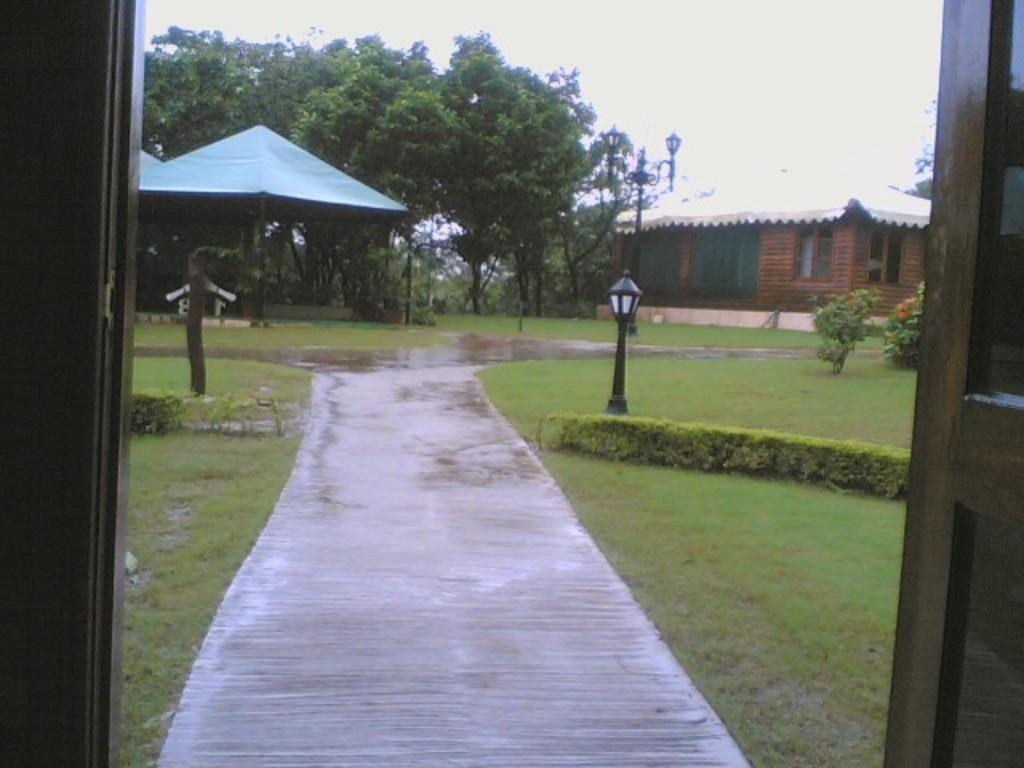Can you describe this image briefly? In this image I can see the road, some grass, few plants, a black colored pole, a shed and few trees. In the background I can see the house, a street light pole, few trees and the sky. 